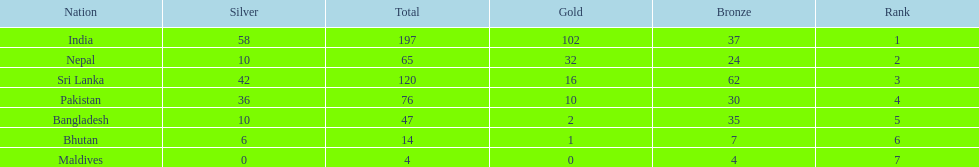What is the difference in total number of medals between india and nepal? 132. 